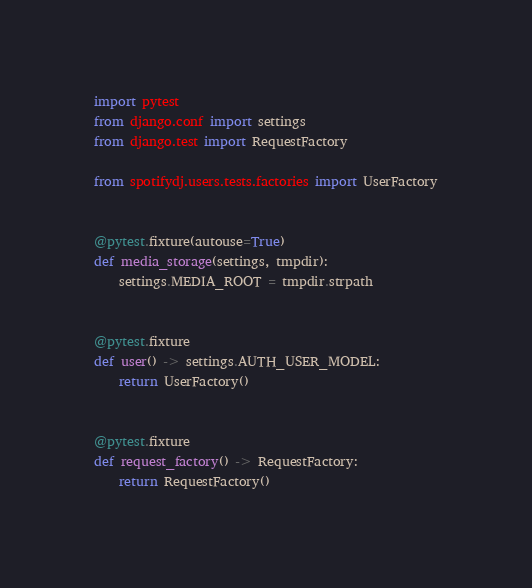Convert code to text. <code><loc_0><loc_0><loc_500><loc_500><_Python_>import pytest
from django.conf import settings
from django.test import RequestFactory

from spotifydj.users.tests.factories import UserFactory


@pytest.fixture(autouse=True)
def media_storage(settings, tmpdir):
    settings.MEDIA_ROOT = tmpdir.strpath


@pytest.fixture
def user() -> settings.AUTH_USER_MODEL:
    return UserFactory()


@pytest.fixture
def request_factory() -> RequestFactory:
    return RequestFactory()
</code> 